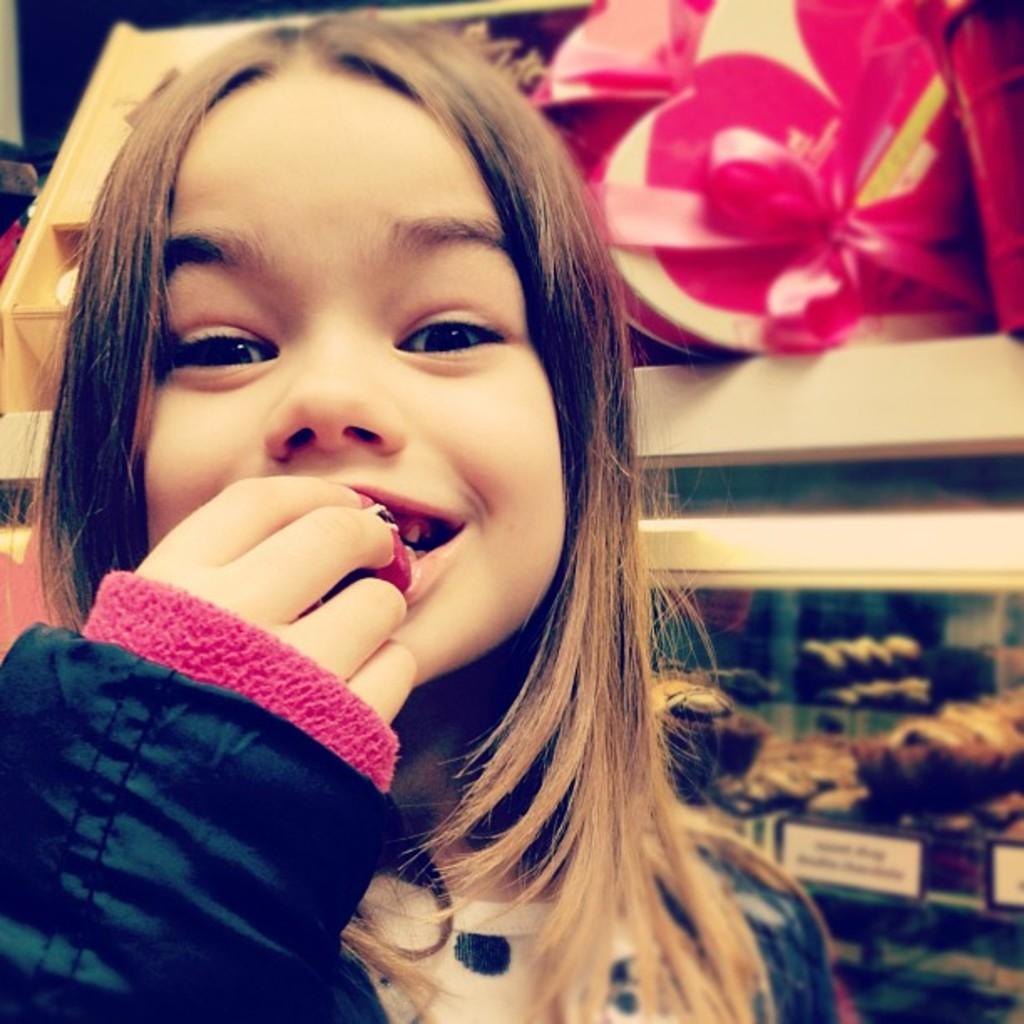How would you summarize this image in a sentence or two? There is one kid eating a food item on the left side of this image. There are some objects are kept in the racks as we can see in the background. 